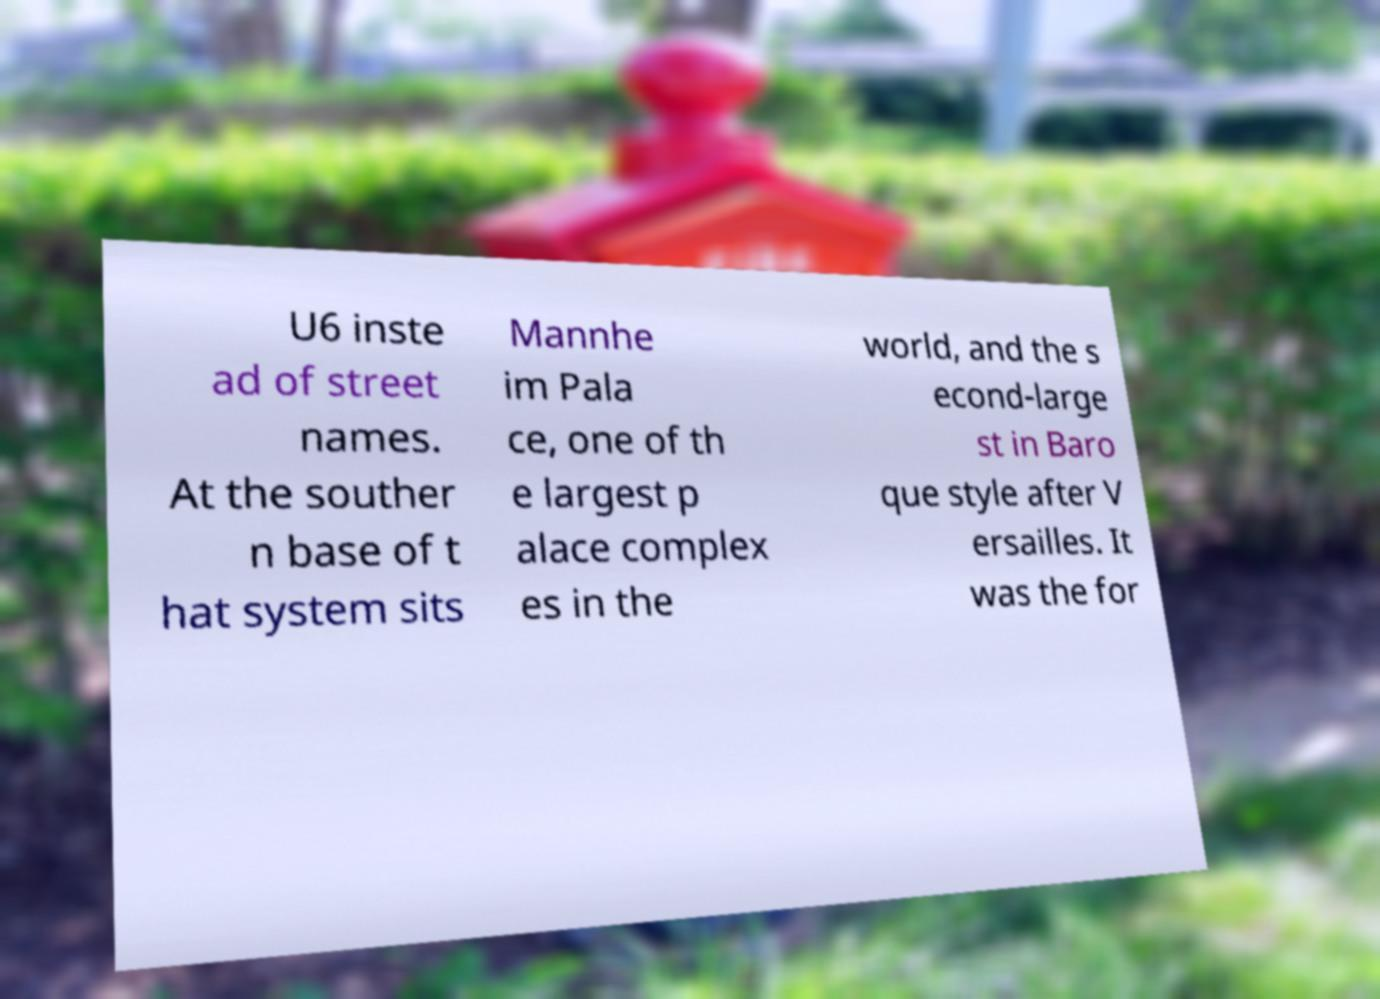For documentation purposes, I need the text within this image transcribed. Could you provide that? U6 inste ad of street names. At the souther n base of t hat system sits Mannhe im Pala ce, one of th e largest p alace complex es in the world, and the s econd-large st in Baro que style after V ersailles. It was the for 